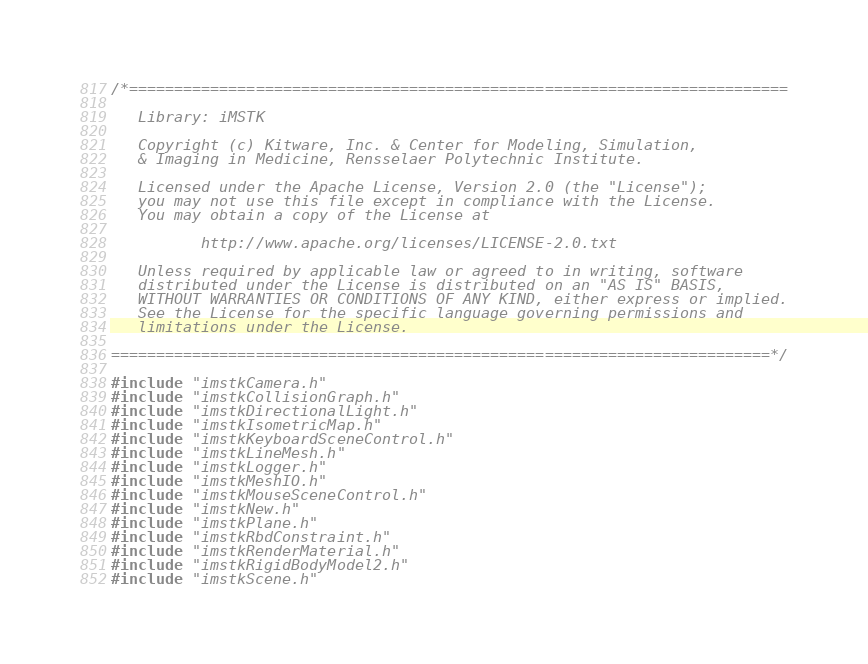Convert code to text. <code><loc_0><loc_0><loc_500><loc_500><_C++_>/*=========================================================================

   Library: iMSTK

   Copyright (c) Kitware, Inc. & Center for Modeling, Simulation,
   & Imaging in Medicine, Rensselaer Polytechnic Institute.

   Licensed under the Apache License, Version 2.0 (the "License");
   you may not use this file except in compliance with the License.
   You may obtain a copy of the License at

          http://www.apache.org/licenses/LICENSE-2.0.txt

   Unless required by applicable law or agreed to in writing, software
   distributed under the License is distributed on an "AS IS" BASIS,
   WITHOUT WARRANTIES OR CONDITIONS OF ANY KIND, either express or implied.
   See the License for the specific language governing permissions and
   limitations under the License.

=========================================================================*/

#include "imstkCamera.h"
#include "imstkCollisionGraph.h"
#include "imstkDirectionalLight.h"
#include "imstkIsometricMap.h"
#include "imstkKeyboardSceneControl.h"
#include "imstkLineMesh.h"
#include "imstkLogger.h"
#include "imstkMeshIO.h"
#include "imstkMouseSceneControl.h"
#include "imstkNew.h"
#include "imstkPlane.h"
#include "imstkRbdConstraint.h"
#include "imstkRenderMaterial.h"
#include "imstkRigidBodyModel2.h"
#include "imstkScene.h"</code> 